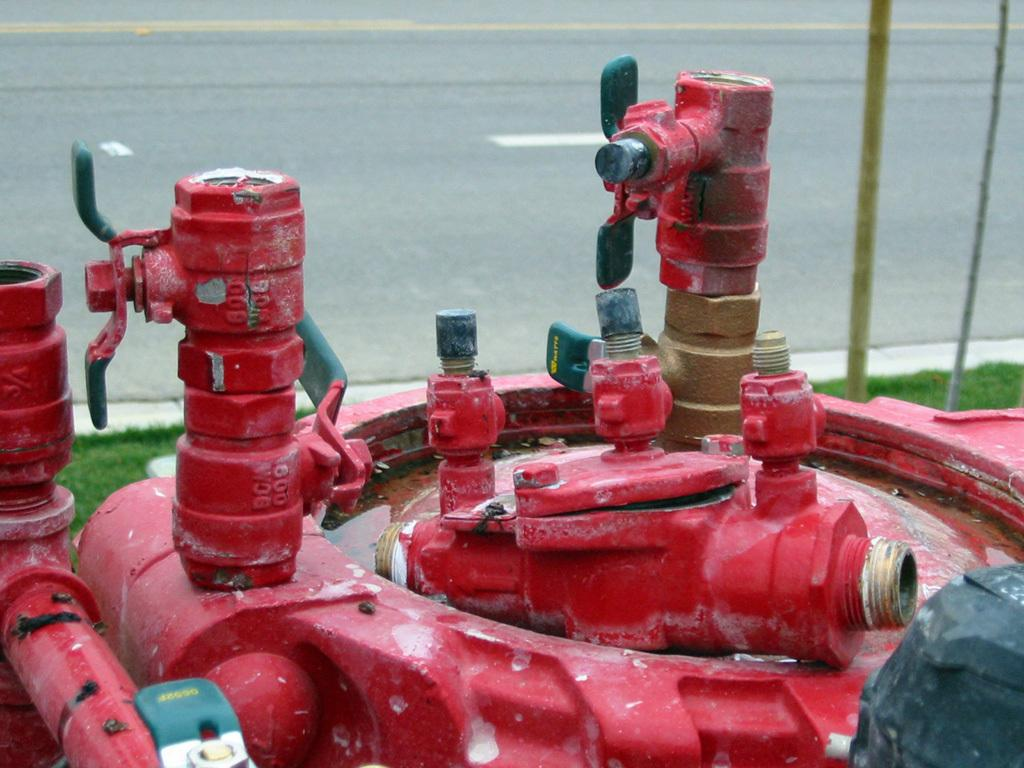What color are the water pipes in the image? The water pipes in the image are red. Where are the water pipes located in the image? The water pipes are located at the bottom of the image. What can be seen behind the water pipes in the image? There is a road visible behind the water pipes. What time of day is it in the image, based on the hour shown on the clock? There is no clock present in the image, so we cannot determine the time of day based on an hour. 